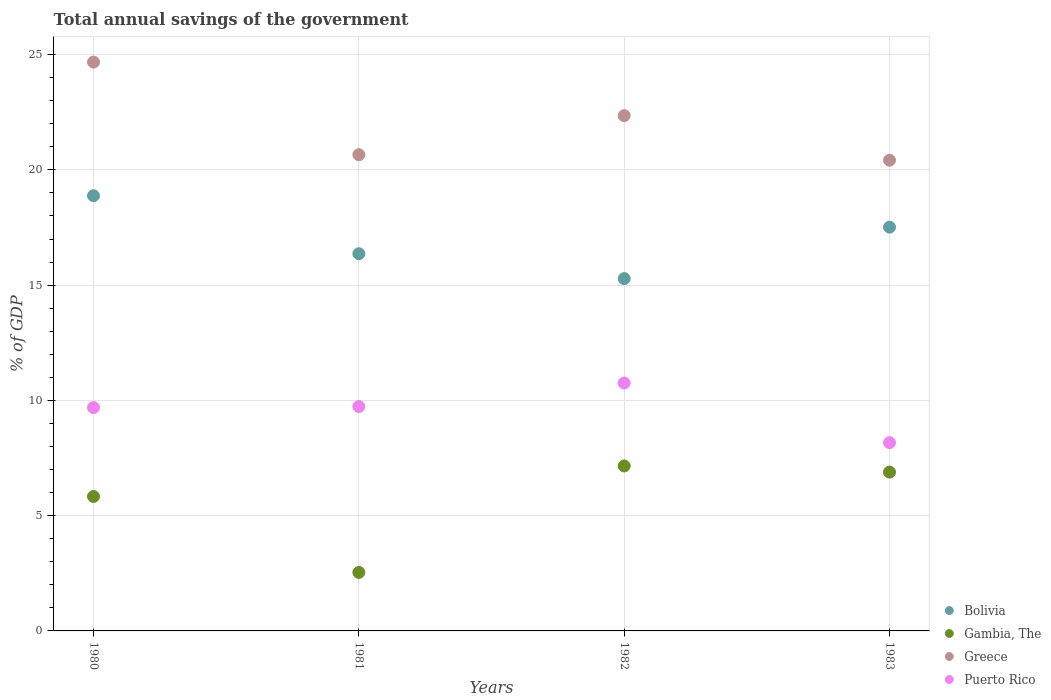How many different coloured dotlines are there?
Your response must be concise. 4. What is the total annual savings of the government in Bolivia in 1981?
Provide a succinct answer. 16.36. Across all years, what is the maximum total annual savings of the government in Greece?
Your answer should be compact. 24.68. Across all years, what is the minimum total annual savings of the government in Bolivia?
Provide a short and direct response. 15.28. In which year was the total annual savings of the government in Greece minimum?
Make the answer very short. 1983. What is the total total annual savings of the government in Greece in the graph?
Your response must be concise. 88.11. What is the difference between the total annual savings of the government in Bolivia in 1981 and that in 1983?
Your answer should be compact. -1.15. What is the difference between the total annual savings of the government in Gambia, The in 1981 and the total annual savings of the government in Puerto Rico in 1980?
Give a very brief answer. -7.15. What is the average total annual savings of the government in Gambia, The per year?
Ensure brevity in your answer.  5.6. In the year 1983, what is the difference between the total annual savings of the government in Greece and total annual savings of the government in Bolivia?
Offer a terse response. 2.9. In how many years, is the total annual savings of the government in Greece greater than 21 %?
Give a very brief answer. 2. What is the ratio of the total annual savings of the government in Puerto Rico in 1980 to that in 1982?
Provide a succinct answer. 0.9. Is the total annual savings of the government in Bolivia in 1982 less than that in 1983?
Provide a succinct answer. Yes. What is the difference between the highest and the second highest total annual savings of the government in Puerto Rico?
Give a very brief answer. 1.02. What is the difference between the highest and the lowest total annual savings of the government in Greece?
Offer a very short reply. 4.26. In how many years, is the total annual savings of the government in Bolivia greater than the average total annual savings of the government in Bolivia taken over all years?
Your answer should be compact. 2. Is it the case that in every year, the sum of the total annual savings of the government in Greece and total annual savings of the government in Bolivia  is greater than the sum of total annual savings of the government in Gambia, The and total annual savings of the government in Puerto Rico?
Your answer should be very brief. Yes. Is the total annual savings of the government in Gambia, The strictly greater than the total annual savings of the government in Puerto Rico over the years?
Ensure brevity in your answer.  No. Does the graph contain any zero values?
Ensure brevity in your answer.  No. Does the graph contain grids?
Your answer should be very brief. Yes. Where does the legend appear in the graph?
Your answer should be compact. Bottom right. How are the legend labels stacked?
Give a very brief answer. Vertical. What is the title of the graph?
Provide a short and direct response. Total annual savings of the government. What is the label or title of the Y-axis?
Ensure brevity in your answer.  % of GDP. What is the % of GDP in Bolivia in 1980?
Your response must be concise. 18.88. What is the % of GDP in Gambia, The in 1980?
Your answer should be compact. 5.83. What is the % of GDP of Greece in 1980?
Ensure brevity in your answer.  24.68. What is the % of GDP of Puerto Rico in 1980?
Your response must be concise. 9.69. What is the % of GDP in Bolivia in 1981?
Offer a very short reply. 16.36. What is the % of GDP of Gambia, The in 1981?
Your response must be concise. 2.54. What is the % of GDP in Greece in 1981?
Your response must be concise. 20.66. What is the % of GDP of Puerto Rico in 1981?
Offer a very short reply. 9.73. What is the % of GDP in Bolivia in 1982?
Make the answer very short. 15.28. What is the % of GDP in Gambia, The in 1982?
Provide a short and direct response. 7.16. What is the % of GDP of Greece in 1982?
Your response must be concise. 22.35. What is the % of GDP of Puerto Rico in 1982?
Make the answer very short. 10.75. What is the % of GDP of Bolivia in 1983?
Offer a very short reply. 17.52. What is the % of GDP in Gambia, The in 1983?
Give a very brief answer. 6.89. What is the % of GDP in Greece in 1983?
Your answer should be very brief. 20.42. What is the % of GDP in Puerto Rico in 1983?
Offer a very short reply. 8.17. Across all years, what is the maximum % of GDP in Bolivia?
Give a very brief answer. 18.88. Across all years, what is the maximum % of GDP in Gambia, The?
Offer a very short reply. 7.16. Across all years, what is the maximum % of GDP in Greece?
Provide a succinct answer. 24.68. Across all years, what is the maximum % of GDP in Puerto Rico?
Make the answer very short. 10.75. Across all years, what is the minimum % of GDP in Bolivia?
Your answer should be compact. 15.28. Across all years, what is the minimum % of GDP of Gambia, The?
Offer a terse response. 2.54. Across all years, what is the minimum % of GDP of Greece?
Ensure brevity in your answer.  20.42. Across all years, what is the minimum % of GDP of Puerto Rico?
Ensure brevity in your answer.  8.17. What is the total % of GDP of Bolivia in the graph?
Your response must be concise. 68.04. What is the total % of GDP in Gambia, The in the graph?
Offer a very short reply. 22.42. What is the total % of GDP of Greece in the graph?
Keep it short and to the point. 88.11. What is the total % of GDP in Puerto Rico in the graph?
Provide a succinct answer. 38.34. What is the difference between the % of GDP in Bolivia in 1980 and that in 1981?
Keep it short and to the point. 2.52. What is the difference between the % of GDP of Gambia, The in 1980 and that in 1981?
Provide a short and direct response. 3.3. What is the difference between the % of GDP in Greece in 1980 and that in 1981?
Make the answer very short. 4.02. What is the difference between the % of GDP in Puerto Rico in 1980 and that in 1981?
Provide a succinct answer. -0.04. What is the difference between the % of GDP in Bolivia in 1980 and that in 1982?
Offer a terse response. 3.6. What is the difference between the % of GDP in Gambia, The in 1980 and that in 1982?
Make the answer very short. -1.32. What is the difference between the % of GDP of Greece in 1980 and that in 1982?
Make the answer very short. 2.32. What is the difference between the % of GDP of Puerto Rico in 1980 and that in 1982?
Provide a short and direct response. -1.06. What is the difference between the % of GDP in Bolivia in 1980 and that in 1983?
Provide a succinct answer. 1.36. What is the difference between the % of GDP of Gambia, The in 1980 and that in 1983?
Your answer should be compact. -1.06. What is the difference between the % of GDP in Greece in 1980 and that in 1983?
Ensure brevity in your answer.  4.26. What is the difference between the % of GDP of Puerto Rico in 1980 and that in 1983?
Provide a short and direct response. 1.52. What is the difference between the % of GDP of Bolivia in 1981 and that in 1982?
Provide a succinct answer. 1.08. What is the difference between the % of GDP in Gambia, The in 1981 and that in 1982?
Offer a terse response. -4.62. What is the difference between the % of GDP of Greece in 1981 and that in 1982?
Offer a very short reply. -1.69. What is the difference between the % of GDP of Puerto Rico in 1981 and that in 1982?
Your answer should be very brief. -1.02. What is the difference between the % of GDP of Bolivia in 1981 and that in 1983?
Ensure brevity in your answer.  -1.15. What is the difference between the % of GDP of Gambia, The in 1981 and that in 1983?
Make the answer very short. -4.35. What is the difference between the % of GDP in Greece in 1981 and that in 1983?
Your answer should be compact. 0.24. What is the difference between the % of GDP in Puerto Rico in 1981 and that in 1983?
Your response must be concise. 1.56. What is the difference between the % of GDP in Bolivia in 1982 and that in 1983?
Make the answer very short. -2.23. What is the difference between the % of GDP in Gambia, The in 1982 and that in 1983?
Ensure brevity in your answer.  0.27. What is the difference between the % of GDP of Greece in 1982 and that in 1983?
Ensure brevity in your answer.  1.93. What is the difference between the % of GDP in Puerto Rico in 1982 and that in 1983?
Your answer should be compact. 2.59. What is the difference between the % of GDP of Bolivia in 1980 and the % of GDP of Gambia, The in 1981?
Provide a succinct answer. 16.34. What is the difference between the % of GDP of Bolivia in 1980 and the % of GDP of Greece in 1981?
Your answer should be compact. -1.78. What is the difference between the % of GDP of Bolivia in 1980 and the % of GDP of Puerto Rico in 1981?
Keep it short and to the point. 9.15. What is the difference between the % of GDP of Gambia, The in 1980 and the % of GDP of Greece in 1981?
Give a very brief answer. -14.83. What is the difference between the % of GDP of Gambia, The in 1980 and the % of GDP of Puerto Rico in 1981?
Provide a succinct answer. -3.9. What is the difference between the % of GDP of Greece in 1980 and the % of GDP of Puerto Rico in 1981?
Keep it short and to the point. 14.94. What is the difference between the % of GDP in Bolivia in 1980 and the % of GDP in Gambia, The in 1982?
Keep it short and to the point. 11.72. What is the difference between the % of GDP of Bolivia in 1980 and the % of GDP of Greece in 1982?
Ensure brevity in your answer.  -3.47. What is the difference between the % of GDP of Bolivia in 1980 and the % of GDP of Puerto Rico in 1982?
Your answer should be very brief. 8.13. What is the difference between the % of GDP of Gambia, The in 1980 and the % of GDP of Greece in 1982?
Your answer should be very brief. -16.52. What is the difference between the % of GDP of Gambia, The in 1980 and the % of GDP of Puerto Rico in 1982?
Your response must be concise. -4.92. What is the difference between the % of GDP of Greece in 1980 and the % of GDP of Puerto Rico in 1982?
Provide a succinct answer. 13.92. What is the difference between the % of GDP in Bolivia in 1980 and the % of GDP in Gambia, The in 1983?
Provide a succinct answer. 11.99. What is the difference between the % of GDP of Bolivia in 1980 and the % of GDP of Greece in 1983?
Your answer should be compact. -1.54. What is the difference between the % of GDP in Bolivia in 1980 and the % of GDP in Puerto Rico in 1983?
Your answer should be compact. 10.71. What is the difference between the % of GDP in Gambia, The in 1980 and the % of GDP in Greece in 1983?
Provide a succinct answer. -14.59. What is the difference between the % of GDP of Gambia, The in 1980 and the % of GDP of Puerto Rico in 1983?
Your response must be concise. -2.34. What is the difference between the % of GDP of Greece in 1980 and the % of GDP of Puerto Rico in 1983?
Provide a short and direct response. 16.51. What is the difference between the % of GDP in Bolivia in 1981 and the % of GDP in Gambia, The in 1982?
Provide a succinct answer. 9.21. What is the difference between the % of GDP in Bolivia in 1981 and the % of GDP in Greece in 1982?
Provide a short and direct response. -5.99. What is the difference between the % of GDP in Bolivia in 1981 and the % of GDP in Puerto Rico in 1982?
Ensure brevity in your answer.  5.61. What is the difference between the % of GDP in Gambia, The in 1981 and the % of GDP in Greece in 1982?
Keep it short and to the point. -19.82. What is the difference between the % of GDP in Gambia, The in 1981 and the % of GDP in Puerto Rico in 1982?
Give a very brief answer. -8.22. What is the difference between the % of GDP in Greece in 1981 and the % of GDP in Puerto Rico in 1982?
Your response must be concise. 9.9. What is the difference between the % of GDP of Bolivia in 1981 and the % of GDP of Gambia, The in 1983?
Offer a very short reply. 9.47. What is the difference between the % of GDP in Bolivia in 1981 and the % of GDP in Greece in 1983?
Give a very brief answer. -4.06. What is the difference between the % of GDP in Bolivia in 1981 and the % of GDP in Puerto Rico in 1983?
Your answer should be compact. 8.2. What is the difference between the % of GDP in Gambia, The in 1981 and the % of GDP in Greece in 1983?
Give a very brief answer. -17.88. What is the difference between the % of GDP in Gambia, The in 1981 and the % of GDP in Puerto Rico in 1983?
Ensure brevity in your answer.  -5.63. What is the difference between the % of GDP in Greece in 1981 and the % of GDP in Puerto Rico in 1983?
Your answer should be compact. 12.49. What is the difference between the % of GDP of Bolivia in 1982 and the % of GDP of Gambia, The in 1983?
Provide a short and direct response. 8.4. What is the difference between the % of GDP in Bolivia in 1982 and the % of GDP in Greece in 1983?
Your answer should be compact. -5.14. What is the difference between the % of GDP of Bolivia in 1982 and the % of GDP of Puerto Rico in 1983?
Make the answer very short. 7.12. What is the difference between the % of GDP in Gambia, The in 1982 and the % of GDP in Greece in 1983?
Ensure brevity in your answer.  -13.26. What is the difference between the % of GDP in Gambia, The in 1982 and the % of GDP in Puerto Rico in 1983?
Give a very brief answer. -1.01. What is the difference between the % of GDP in Greece in 1982 and the % of GDP in Puerto Rico in 1983?
Make the answer very short. 14.19. What is the average % of GDP in Bolivia per year?
Your answer should be compact. 17.01. What is the average % of GDP of Gambia, The per year?
Your answer should be very brief. 5.6. What is the average % of GDP in Greece per year?
Ensure brevity in your answer.  22.03. What is the average % of GDP in Puerto Rico per year?
Your response must be concise. 9.59. In the year 1980, what is the difference between the % of GDP in Bolivia and % of GDP in Gambia, The?
Make the answer very short. 13.05. In the year 1980, what is the difference between the % of GDP of Bolivia and % of GDP of Greece?
Make the answer very short. -5.8. In the year 1980, what is the difference between the % of GDP of Bolivia and % of GDP of Puerto Rico?
Give a very brief answer. 9.19. In the year 1980, what is the difference between the % of GDP in Gambia, The and % of GDP in Greece?
Ensure brevity in your answer.  -18.84. In the year 1980, what is the difference between the % of GDP in Gambia, The and % of GDP in Puerto Rico?
Your response must be concise. -3.86. In the year 1980, what is the difference between the % of GDP of Greece and % of GDP of Puerto Rico?
Provide a short and direct response. 14.99. In the year 1981, what is the difference between the % of GDP in Bolivia and % of GDP in Gambia, The?
Your answer should be compact. 13.83. In the year 1981, what is the difference between the % of GDP in Bolivia and % of GDP in Greece?
Offer a terse response. -4.3. In the year 1981, what is the difference between the % of GDP of Bolivia and % of GDP of Puerto Rico?
Your response must be concise. 6.63. In the year 1981, what is the difference between the % of GDP of Gambia, The and % of GDP of Greece?
Offer a terse response. -18.12. In the year 1981, what is the difference between the % of GDP of Gambia, The and % of GDP of Puerto Rico?
Your response must be concise. -7.19. In the year 1981, what is the difference between the % of GDP of Greece and % of GDP of Puerto Rico?
Make the answer very short. 10.93. In the year 1982, what is the difference between the % of GDP of Bolivia and % of GDP of Gambia, The?
Ensure brevity in your answer.  8.13. In the year 1982, what is the difference between the % of GDP of Bolivia and % of GDP of Greece?
Your answer should be compact. -7.07. In the year 1982, what is the difference between the % of GDP of Bolivia and % of GDP of Puerto Rico?
Offer a terse response. 4.53. In the year 1982, what is the difference between the % of GDP in Gambia, The and % of GDP in Greece?
Your answer should be compact. -15.2. In the year 1982, what is the difference between the % of GDP in Gambia, The and % of GDP in Puerto Rico?
Your response must be concise. -3.6. In the year 1982, what is the difference between the % of GDP of Greece and % of GDP of Puerto Rico?
Provide a succinct answer. 11.6. In the year 1983, what is the difference between the % of GDP in Bolivia and % of GDP in Gambia, The?
Your answer should be very brief. 10.63. In the year 1983, what is the difference between the % of GDP of Bolivia and % of GDP of Greece?
Keep it short and to the point. -2.9. In the year 1983, what is the difference between the % of GDP in Bolivia and % of GDP in Puerto Rico?
Make the answer very short. 9.35. In the year 1983, what is the difference between the % of GDP in Gambia, The and % of GDP in Greece?
Offer a terse response. -13.53. In the year 1983, what is the difference between the % of GDP of Gambia, The and % of GDP of Puerto Rico?
Make the answer very short. -1.28. In the year 1983, what is the difference between the % of GDP of Greece and % of GDP of Puerto Rico?
Provide a short and direct response. 12.25. What is the ratio of the % of GDP in Bolivia in 1980 to that in 1981?
Your response must be concise. 1.15. What is the ratio of the % of GDP in Gambia, The in 1980 to that in 1981?
Provide a succinct answer. 2.3. What is the ratio of the % of GDP of Greece in 1980 to that in 1981?
Make the answer very short. 1.19. What is the ratio of the % of GDP in Bolivia in 1980 to that in 1982?
Your response must be concise. 1.24. What is the ratio of the % of GDP in Gambia, The in 1980 to that in 1982?
Provide a short and direct response. 0.82. What is the ratio of the % of GDP in Greece in 1980 to that in 1982?
Keep it short and to the point. 1.1. What is the ratio of the % of GDP of Puerto Rico in 1980 to that in 1982?
Make the answer very short. 0.9. What is the ratio of the % of GDP of Bolivia in 1980 to that in 1983?
Give a very brief answer. 1.08. What is the ratio of the % of GDP of Gambia, The in 1980 to that in 1983?
Make the answer very short. 0.85. What is the ratio of the % of GDP in Greece in 1980 to that in 1983?
Give a very brief answer. 1.21. What is the ratio of the % of GDP of Puerto Rico in 1980 to that in 1983?
Keep it short and to the point. 1.19. What is the ratio of the % of GDP in Bolivia in 1981 to that in 1982?
Provide a short and direct response. 1.07. What is the ratio of the % of GDP in Gambia, The in 1981 to that in 1982?
Offer a very short reply. 0.35. What is the ratio of the % of GDP in Greece in 1981 to that in 1982?
Offer a very short reply. 0.92. What is the ratio of the % of GDP of Puerto Rico in 1981 to that in 1982?
Make the answer very short. 0.91. What is the ratio of the % of GDP in Bolivia in 1981 to that in 1983?
Provide a short and direct response. 0.93. What is the ratio of the % of GDP of Gambia, The in 1981 to that in 1983?
Your answer should be very brief. 0.37. What is the ratio of the % of GDP of Greece in 1981 to that in 1983?
Ensure brevity in your answer.  1.01. What is the ratio of the % of GDP of Puerto Rico in 1981 to that in 1983?
Your answer should be very brief. 1.19. What is the ratio of the % of GDP in Bolivia in 1982 to that in 1983?
Offer a very short reply. 0.87. What is the ratio of the % of GDP of Gambia, The in 1982 to that in 1983?
Your response must be concise. 1.04. What is the ratio of the % of GDP of Greece in 1982 to that in 1983?
Your answer should be very brief. 1.09. What is the ratio of the % of GDP of Puerto Rico in 1982 to that in 1983?
Provide a succinct answer. 1.32. What is the difference between the highest and the second highest % of GDP in Bolivia?
Keep it short and to the point. 1.36. What is the difference between the highest and the second highest % of GDP of Gambia, The?
Provide a succinct answer. 0.27. What is the difference between the highest and the second highest % of GDP in Greece?
Your answer should be compact. 2.32. What is the difference between the highest and the second highest % of GDP of Puerto Rico?
Give a very brief answer. 1.02. What is the difference between the highest and the lowest % of GDP in Bolivia?
Offer a terse response. 3.6. What is the difference between the highest and the lowest % of GDP of Gambia, The?
Make the answer very short. 4.62. What is the difference between the highest and the lowest % of GDP of Greece?
Make the answer very short. 4.26. What is the difference between the highest and the lowest % of GDP of Puerto Rico?
Offer a terse response. 2.59. 